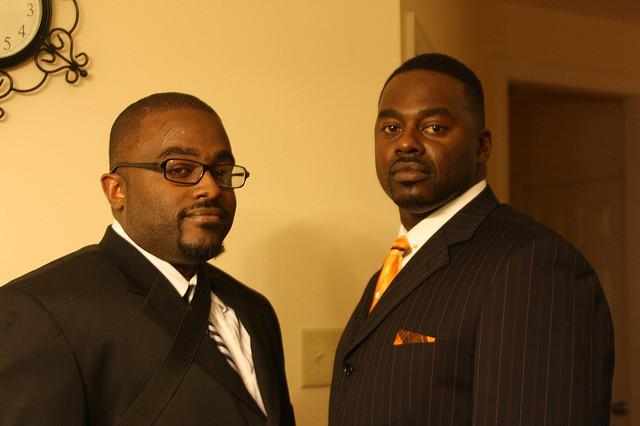What are the men's ethnicity?
Be succinct. African american. What organization does he work for?
Answer briefly. Church. Are these clothes the men would wear to work?
Be succinct. Yes. Are both men wearing pinstripe suits?
Concise answer only. No. Is this scene indoors?
Be succinct. Yes. What color are the men's ties?
Short answer required. Gold. Who is wearing glasses?
Quick response, please. Left man. 